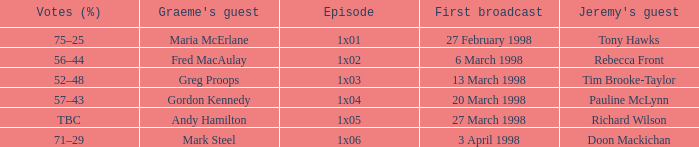What is Votes (%), when First Broadcast is "13 March 1998"? 52–48. 